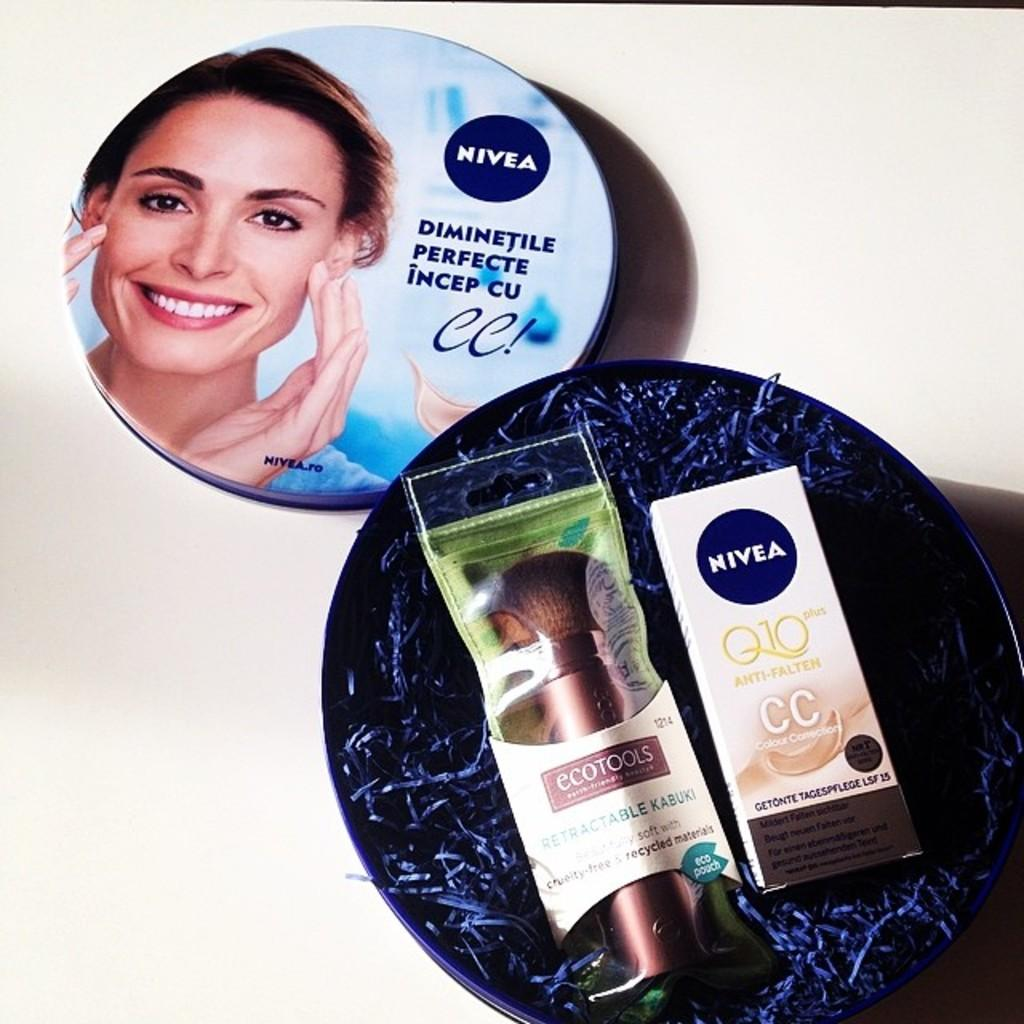<image>
Give a short and clear explanation of the subsequent image. a few bottles of Nivea on blue surfaces on the ground 